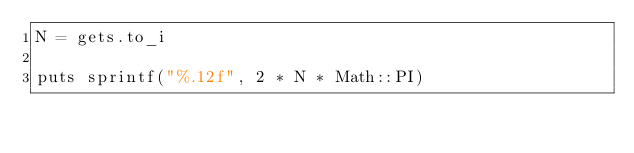<code> <loc_0><loc_0><loc_500><loc_500><_Ruby_>N = gets.to_i

puts sprintf("%.12f", 2 * N * Math::PI)
</code> 